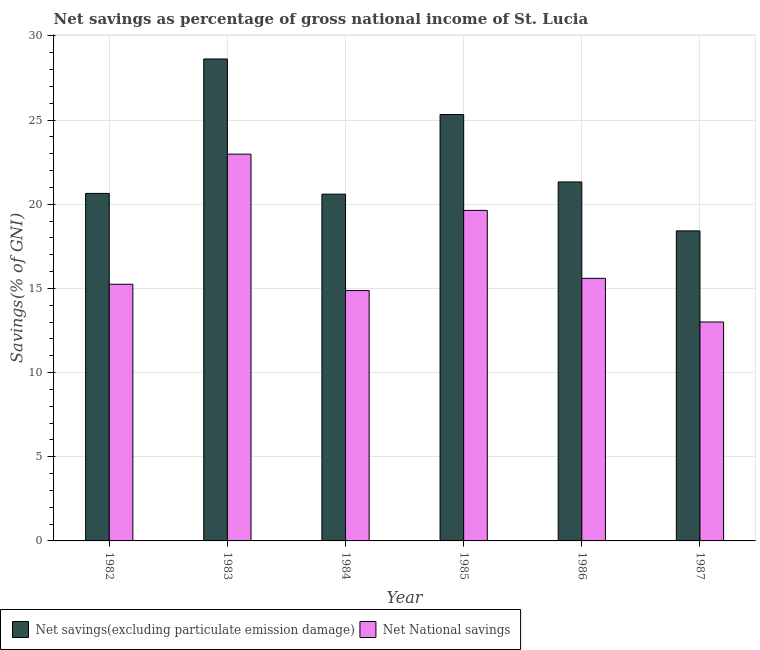How many groups of bars are there?
Give a very brief answer. 6. Are the number of bars on each tick of the X-axis equal?
Your answer should be compact. Yes. What is the net national savings in 1982?
Ensure brevity in your answer.  15.25. Across all years, what is the maximum net savings(excluding particulate emission damage)?
Provide a succinct answer. 28.62. Across all years, what is the minimum net savings(excluding particulate emission damage)?
Ensure brevity in your answer.  18.41. In which year was the net savings(excluding particulate emission damage) maximum?
Provide a short and direct response. 1983. In which year was the net savings(excluding particulate emission damage) minimum?
Your answer should be compact. 1987. What is the total net savings(excluding particulate emission damage) in the graph?
Provide a succinct answer. 134.92. What is the difference between the net savings(excluding particulate emission damage) in 1986 and that in 1987?
Offer a very short reply. 2.91. What is the difference between the net national savings in 1987 and the net savings(excluding particulate emission damage) in 1983?
Offer a terse response. -9.97. What is the average net national savings per year?
Provide a short and direct response. 16.89. In the year 1985, what is the difference between the net savings(excluding particulate emission damage) and net national savings?
Ensure brevity in your answer.  0. In how many years, is the net savings(excluding particulate emission damage) greater than 17 %?
Your answer should be very brief. 6. What is the ratio of the net national savings in 1982 to that in 1987?
Offer a terse response. 1.17. What is the difference between the highest and the second highest net national savings?
Make the answer very short. 3.34. What is the difference between the highest and the lowest net national savings?
Provide a succinct answer. 9.97. Is the sum of the net savings(excluding particulate emission damage) in 1985 and 1986 greater than the maximum net national savings across all years?
Offer a terse response. Yes. What does the 2nd bar from the left in 1987 represents?
Ensure brevity in your answer.  Net National savings. What does the 2nd bar from the right in 1982 represents?
Offer a terse response. Net savings(excluding particulate emission damage). How many bars are there?
Ensure brevity in your answer.  12. Are all the bars in the graph horizontal?
Offer a very short reply. No. What is the difference between two consecutive major ticks on the Y-axis?
Your response must be concise. 5. How many legend labels are there?
Offer a terse response. 2. How are the legend labels stacked?
Give a very brief answer. Horizontal. What is the title of the graph?
Your response must be concise. Net savings as percentage of gross national income of St. Lucia. What is the label or title of the X-axis?
Provide a succinct answer. Year. What is the label or title of the Y-axis?
Your response must be concise. Savings(% of GNI). What is the Savings(% of GNI) in Net savings(excluding particulate emission damage) in 1982?
Your response must be concise. 20.64. What is the Savings(% of GNI) in Net National savings in 1982?
Provide a succinct answer. 15.25. What is the Savings(% of GNI) in Net savings(excluding particulate emission damage) in 1983?
Your response must be concise. 28.62. What is the Savings(% of GNI) in Net National savings in 1983?
Give a very brief answer. 22.97. What is the Savings(% of GNI) of Net savings(excluding particulate emission damage) in 1984?
Your answer should be very brief. 20.6. What is the Savings(% of GNI) in Net National savings in 1984?
Provide a succinct answer. 14.87. What is the Savings(% of GNI) in Net savings(excluding particulate emission damage) in 1985?
Give a very brief answer. 25.32. What is the Savings(% of GNI) of Net National savings in 1985?
Provide a short and direct response. 19.63. What is the Savings(% of GNI) of Net savings(excluding particulate emission damage) in 1986?
Keep it short and to the point. 21.32. What is the Savings(% of GNI) of Net National savings in 1986?
Your answer should be compact. 15.59. What is the Savings(% of GNI) in Net savings(excluding particulate emission damage) in 1987?
Ensure brevity in your answer.  18.41. What is the Savings(% of GNI) of Net National savings in 1987?
Give a very brief answer. 13. Across all years, what is the maximum Savings(% of GNI) of Net savings(excluding particulate emission damage)?
Give a very brief answer. 28.62. Across all years, what is the maximum Savings(% of GNI) in Net National savings?
Offer a very short reply. 22.97. Across all years, what is the minimum Savings(% of GNI) of Net savings(excluding particulate emission damage)?
Provide a succinct answer. 18.41. Across all years, what is the minimum Savings(% of GNI) of Net National savings?
Provide a succinct answer. 13. What is the total Savings(% of GNI) in Net savings(excluding particulate emission damage) in the graph?
Provide a short and direct response. 134.92. What is the total Savings(% of GNI) in Net National savings in the graph?
Provide a short and direct response. 101.32. What is the difference between the Savings(% of GNI) of Net savings(excluding particulate emission damage) in 1982 and that in 1983?
Your response must be concise. -7.98. What is the difference between the Savings(% of GNI) in Net National savings in 1982 and that in 1983?
Give a very brief answer. -7.73. What is the difference between the Savings(% of GNI) of Net savings(excluding particulate emission damage) in 1982 and that in 1984?
Your answer should be compact. 0.04. What is the difference between the Savings(% of GNI) in Net National savings in 1982 and that in 1984?
Your answer should be very brief. 0.38. What is the difference between the Savings(% of GNI) of Net savings(excluding particulate emission damage) in 1982 and that in 1985?
Your answer should be very brief. -4.68. What is the difference between the Savings(% of GNI) in Net National savings in 1982 and that in 1985?
Provide a short and direct response. -4.39. What is the difference between the Savings(% of GNI) of Net savings(excluding particulate emission damage) in 1982 and that in 1986?
Keep it short and to the point. -0.68. What is the difference between the Savings(% of GNI) in Net National savings in 1982 and that in 1986?
Ensure brevity in your answer.  -0.35. What is the difference between the Savings(% of GNI) in Net savings(excluding particulate emission damage) in 1982 and that in 1987?
Your response must be concise. 2.23. What is the difference between the Savings(% of GNI) of Net National savings in 1982 and that in 1987?
Your answer should be very brief. 2.24. What is the difference between the Savings(% of GNI) in Net savings(excluding particulate emission damage) in 1983 and that in 1984?
Ensure brevity in your answer.  8.03. What is the difference between the Savings(% of GNI) in Net National savings in 1983 and that in 1984?
Your response must be concise. 8.1. What is the difference between the Savings(% of GNI) in Net savings(excluding particulate emission damage) in 1983 and that in 1985?
Provide a short and direct response. 3.3. What is the difference between the Savings(% of GNI) of Net National savings in 1983 and that in 1985?
Ensure brevity in your answer.  3.34. What is the difference between the Savings(% of GNI) of Net savings(excluding particulate emission damage) in 1983 and that in 1986?
Ensure brevity in your answer.  7.3. What is the difference between the Savings(% of GNI) of Net National savings in 1983 and that in 1986?
Give a very brief answer. 7.38. What is the difference between the Savings(% of GNI) of Net savings(excluding particulate emission damage) in 1983 and that in 1987?
Provide a succinct answer. 10.21. What is the difference between the Savings(% of GNI) in Net National savings in 1983 and that in 1987?
Offer a very short reply. 9.97. What is the difference between the Savings(% of GNI) in Net savings(excluding particulate emission damage) in 1984 and that in 1985?
Keep it short and to the point. -4.73. What is the difference between the Savings(% of GNI) in Net National savings in 1984 and that in 1985?
Make the answer very short. -4.76. What is the difference between the Savings(% of GNI) in Net savings(excluding particulate emission damage) in 1984 and that in 1986?
Ensure brevity in your answer.  -0.72. What is the difference between the Savings(% of GNI) of Net National savings in 1984 and that in 1986?
Provide a succinct answer. -0.72. What is the difference between the Savings(% of GNI) in Net savings(excluding particulate emission damage) in 1984 and that in 1987?
Provide a succinct answer. 2.18. What is the difference between the Savings(% of GNI) of Net National savings in 1984 and that in 1987?
Give a very brief answer. 1.87. What is the difference between the Savings(% of GNI) of Net savings(excluding particulate emission damage) in 1985 and that in 1986?
Your answer should be compact. 4. What is the difference between the Savings(% of GNI) in Net National savings in 1985 and that in 1986?
Provide a short and direct response. 4.04. What is the difference between the Savings(% of GNI) in Net savings(excluding particulate emission damage) in 1985 and that in 1987?
Provide a succinct answer. 6.91. What is the difference between the Savings(% of GNI) of Net National savings in 1985 and that in 1987?
Your response must be concise. 6.63. What is the difference between the Savings(% of GNI) in Net savings(excluding particulate emission damage) in 1986 and that in 1987?
Provide a short and direct response. 2.91. What is the difference between the Savings(% of GNI) in Net National savings in 1986 and that in 1987?
Keep it short and to the point. 2.59. What is the difference between the Savings(% of GNI) in Net savings(excluding particulate emission damage) in 1982 and the Savings(% of GNI) in Net National savings in 1983?
Make the answer very short. -2.33. What is the difference between the Savings(% of GNI) in Net savings(excluding particulate emission damage) in 1982 and the Savings(% of GNI) in Net National savings in 1984?
Your response must be concise. 5.77. What is the difference between the Savings(% of GNI) in Net savings(excluding particulate emission damage) in 1982 and the Savings(% of GNI) in Net National savings in 1985?
Provide a short and direct response. 1.01. What is the difference between the Savings(% of GNI) in Net savings(excluding particulate emission damage) in 1982 and the Savings(% of GNI) in Net National savings in 1986?
Your answer should be very brief. 5.05. What is the difference between the Savings(% of GNI) of Net savings(excluding particulate emission damage) in 1982 and the Savings(% of GNI) of Net National savings in 1987?
Keep it short and to the point. 7.64. What is the difference between the Savings(% of GNI) of Net savings(excluding particulate emission damage) in 1983 and the Savings(% of GNI) of Net National savings in 1984?
Give a very brief answer. 13.76. What is the difference between the Savings(% of GNI) of Net savings(excluding particulate emission damage) in 1983 and the Savings(% of GNI) of Net National savings in 1985?
Your answer should be very brief. 8.99. What is the difference between the Savings(% of GNI) of Net savings(excluding particulate emission damage) in 1983 and the Savings(% of GNI) of Net National savings in 1986?
Make the answer very short. 13.03. What is the difference between the Savings(% of GNI) of Net savings(excluding particulate emission damage) in 1983 and the Savings(% of GNI) of Net National savings in 1987?
Provide a succinct answer. 15.62. What is the difference between the Savings(% of GNI) in Net savings(excluding particulate emission damage) in 1984 and the Savings(% of GNI) in Net National savings in 1985?
Offer a terse response. 0.96. What is the difference between the Savings(% of GNI) in Net savings(excluding particulate emission damage) in 1984 and the Savings(% of GNI) in Net National savings in 1986?
Your answer should be very brief. 5. What is the difference between the Savings(% of GNI) of Net savings(excluding particulate emission damage) in 1984 and the Savings(% of GNI) of Net National savings in 1987?
Offer a terse response. 7.59. What is the difference between the Savings(% of GNI) of Net savings(excluding particulate emission damage) in 1985 and the Savings(% of GNI) of Net National savings in 1986?
Keep it short and to the point. 9.73. What is the difference between the Savings(% of GNI) of Net savings(excluding particulate emission damage) in 1985 and the Savings(% of GNI) of Net National savings in 1987?
Keep it short and to the point. 12.32. What is the difference between the Savings(% of GNI) of Net savings(excluding particulate emission damage) in 1986 and the Savings(% of GNI) of Net National savings in 1987?
Provide a short and direct response. 8.32. What is the average Savings(% of GNI) of Net savings(excluding particulate emission damage) per year?
Offer a very short reply. 22.49. What is the average Savings(% of GNI) in Net National savings per year?
Your answer should be compact. 16.89. In the year 1982, what is the difference between the Savings(% of GNI) in Net savings(excluding particulate emission damage) and Savings(% of GNI) in Net National savings?
Provide a succinct answer. 5.39. In the year 1983, what is the difference between the Savings(% of GNI) in Net savings(excluding particulate emission damage) and Savings(% of GNI) in Net National savings?
Give a very brief answer. 5.65. In the year 1984, what is the difference between the Savings(% of GNI) in Net savings(excluding particulate emission damage) and Savings(% of GNI) in Net National savings?
Keep it short and to the point. 5.73. In the year 1985, what is the difference between the Savings(% of GNI) of Net savings(excluding particulate emission damage) and Savings(% of GNI) of Net National savings?
Offer a very short reply. 5.69. In the year 1986, what is the difference between the Savings(% of GNI) of Net savings(excluding particulate emission damage) and Savings(% of GNI) of Net National savings?
Your response must be concise. 5.73. In the year 1987, what is the difference between the Savings(% of GNI) in Net savings(excluding particulate emission damage) and Savings(% of GNI) in Net National savings?
Make the answer very short. 5.41. What is the ratio of the Savings(% of GNI) of Net savings(excluding particulate emission damage) in 1982 to that in 1983?
Your response must be concise. 0.72. What is the ratio of the Savings(% of GNI) of Net National savings in 1982 to that in 1983?
Offer a very short reply. 0.66. What is the ratio of the Savings(% of GNI) in Net savings(excluding particulate emission damage) in 1982 to that in 1984?
Your answer should be compact. 1. What is the ratio of the Savings(% of GNI) of Net National savings in 1982 to that in 1984?
Your response must be concise. 1.03. What is the ratio of the Savings(% of GNI) in Net savings(excluding particulate emission damage) in 1982 to that in 1985?
Offer a very short reply. 0.82. What is the ratio of the Savings(% of GNI) in Net National savings in 1982 to that in 1985?
Provide a short and direct response. 0.78. What is the ratio of the Savings(% of GNI) in Net savings(excluding particulate emission damage) in 1982 to that in 1986?
Ensure brevity in your answer.  0.97. What is the ratio of the Savings(% of GNI) of Net National savings in 1982 to that in 1986?
Ensure brevity in your answer.  0.98. What is the ratio of the Savings(% of GNI) of Net savings(excluding particulate emission damage) in 1982 to that in 1987?
Ensure brevity in your answer.  1.12. What is the ratio of the Savings(% of GNI) of Net National savings in 1982 to that in 1987?
Your answer should be compact. 1.17. What is the ratio of the Savings(% of GNI) of Net savings(excluding particulate emission damage) in 1983 to that in 1984?
Your answer should be compact. 1.39. What is the ratio of the Savings(% of GNI) of Net National savings in 1983 to that in 1984?
Your answer should be compact. 1.54. What is the ratio of the Savings(% of GNI) of Net savings(excluding particulate emission damage) in 1983 to that in 1985?
Keep it short and to the point. 1.13. What is the ratio of the Savings(% of GNI) in Net National savings in 1983 to that in 1985?
Provide a succinct answer. 1.17. What is the ratio of the Savings(% of GNI) of Net savings(excluding particulate emission damage) in 1983 to that in 1986?
Your answer should be compact. 1.34. What is the ratio of the Savings(% of GNI) in Net National savings in 1983 to that in 1986?
Your answer should be compact. 1.47. What is the ratio of the Savings(% of GNI) of Net savings(excluding particulate emission damage) in 1983 to that in 1987?
Your answer should be compact. 1.55. What is the ratio of the Savings(% of GNI) of Net National savings in 1983 to that in 1987?
Make the answer very short. 1.77. What is the ratio of the Savings(% of GNI) of Net savings(excluding particulate emission damage) in 1984 to that in 1985?
Keep it short and to the point. 0.81. What is the ratio of the Savings(% of GNI) of Net National savings in 1984 to that in 1985?
Provide a succinct answer. 0.76. What is the ratio of the Savings(% of GNI) of Net National savings in 1984 to that in 1986?
Give a very brief answer. 0.95. What is the ratio of the Savings(% of GNI) of Net savings(excluding particulate emission damage) in 1984 to that in 1987?
Provide a short and direct response. 1.12. What is the ratio of the Savings(% of GNI) in Net National savings in 1984 to that in 1987?
Your answer should be compact. 1.14. What is the ratio of the Savings(% of GNI) in Net savings(excluding particulate emission damage) in 1985 to that in 1986?
Give a very brief answer. 1.19. What is the ratio of the Savings(% of GNI) in Net National savings in 1985 to that in 1986?
Keep it short and to the point. 1.26. What is the ratio of the Savings(% of GNI) in Net savings(excluding particulate emission damage) in 1985 to that in 1987?
Offer a terse response. 1.38. What is the ratio of the Savings(% of GNI) of Net National savings in 1985 to that in 1987?
Make the answer very short. 1.51. What is the ratio of the Savings(% of GNI) in Net savings(excluding particulate emission damage) in 1986 to that in 1987?
Keep it short and to the point. 1.16. What is the ratio of the Savings(% of GNI) in Net National savings in 1986 to that in 1987?
Your answer should be very brief. 1.2. What is the difference between the highest and the second highest Savings(% of GNI) in Net savings(excluding particulate emission damage)?
Keep it short and to the point. 3.3. What is the difference between the highest and the second highest Savings(% of GNI) in Net National savings?
Offer a terse response. 3.34. What is the difference between the highest and the lowest Savings(% of GNI) in Net savings(excluding particulate emission damage)?
Keep it short and to the point. 10.21. What is the difference between the highest and the lowest Savings(% of GNI) of Net National savings?
Give a very brief answer. 9.97. 